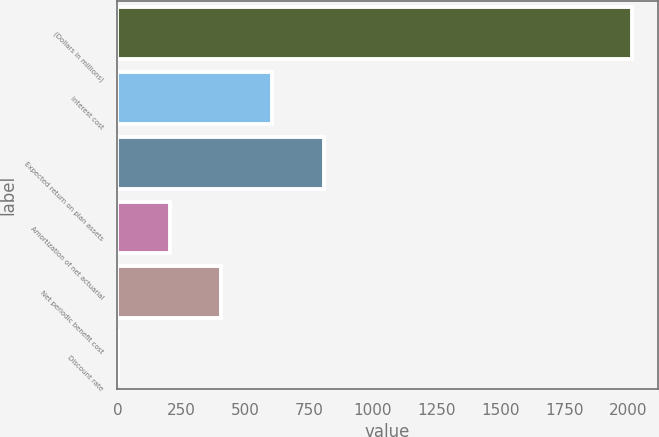Convert chart to OTSL. <chart><loc_0><loc_0><loc_500><loc_500><bar_chart><fcel>(Dollars in millions)<fcel>Interest cost<fcel>Expected return on plan assets<fcel>Amortization of net actuarial<fcel>Net periodic benefit cost<fcel>Discount rate<nl><fcel>2015<fcel>606.98<fcel>808.12<fcel>204.7<fcel>405.84<fcel>3.56<nl></chart> 